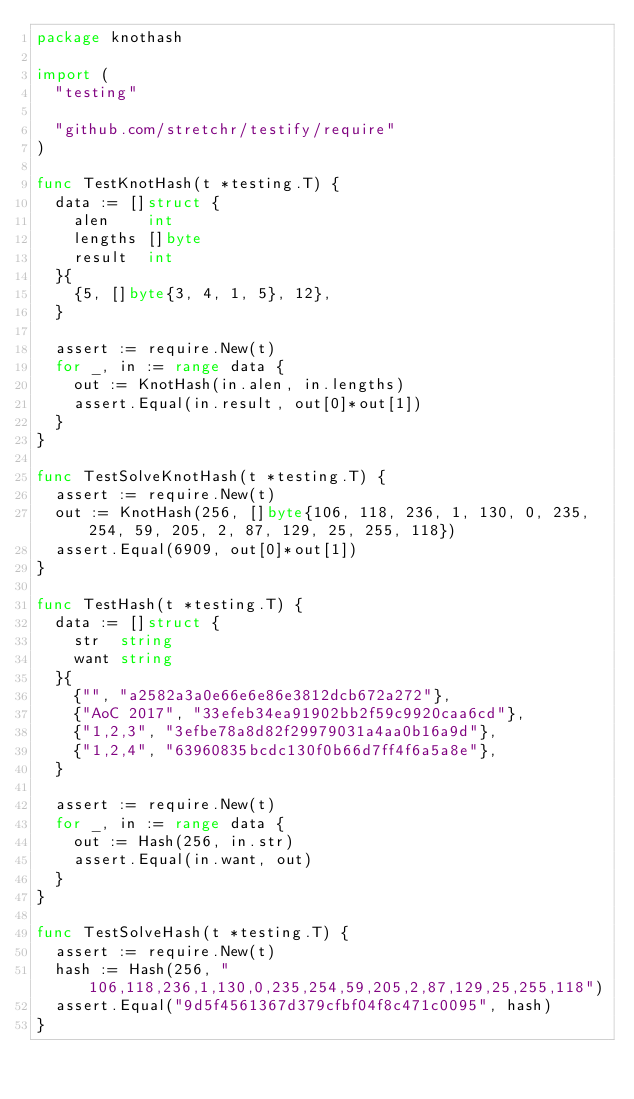<code> <loc_0><loc_0><loc_500><loc_500><_Go_>package knothash

import (
	"testing"

	"github.com/stretchr/testify/require"
)

func TestKnotHash(t *testing.T) {
	data := []struct {
		alen    int
		lengths []byte
		result  int
	}{
		{5, []byte{3, 4, 1, 5}, 12},
	}

	assert := require.New(t)
	for _, in := range data {
		out := KnotHash(in.alen, in.lengths)
		assert.Equal(in.result, out[0]*out[1])
	}
}

func TestSolveKnotHash(t *testing.T) {
	assert := require.New(t)
	out := KnotHash(256, []byte{106, 118, 236, 1, 130, 0, 235, 254, 59, 205, 2, 87, 129, 25, 255, 118})
	assert.Equal(6909, out[0]*out[1])
}

func TestHash(t *testing.T) {
	data := []struct {
		str  string
		want string
	}{
		{"", "a2582a3a0e66e6e86e3812dcb672a272"},
		{"AoC 2017", "33efeb34ea91902bb2f59c9920caa6cd"},
		{"1,2,3", "3efbe78a8d82f29979031a4aa0b16a9d"},
		{"1,2,4", "63960835bcdc130f0b66d7ff4f6a5a8e"},
	}

	assert := require.New(t)
	for _, in := range data {
		out := Hash(256, in.str)
		assert.Equal(in.want, out)
	}
}

func TestSolveHash(t *testing.T) {
	assert := require.New(t)
	hash := Hash(256, "106,118,236,1,130,0,235,254,59,205,2,87,129,25,255,118")
	assert.Equal("9d5f4561367d379cfbf04f8c471c0095", hash)
}
</code> 